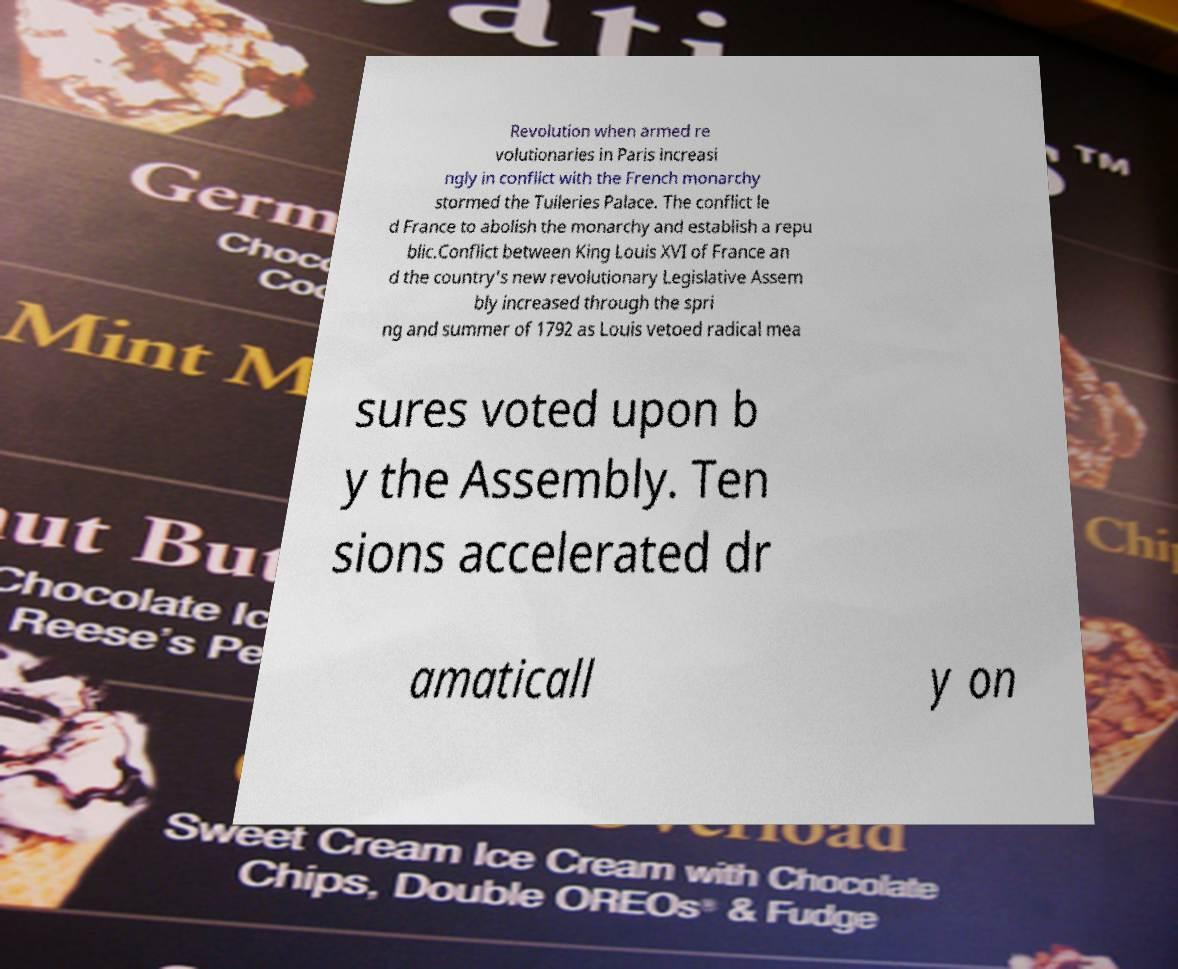What messages or text are displayed in this image? I need them in a readable, typed format. Revolution when armed re volutionaries in Paris increasi ngly in conflict with the French monarchy stormed the Tuileries Palace. The conflict le d France to abolish the monarchy and establish a repu blic.Conflict between King Louis XVI of France an d the country's new revolutionary Legislative Assem bly increased through the spri ng and summer of 1792 as Louis vetoed radical mea sures voted upon b y the Assembly. Ten sions accelerated dr amaticall y on 